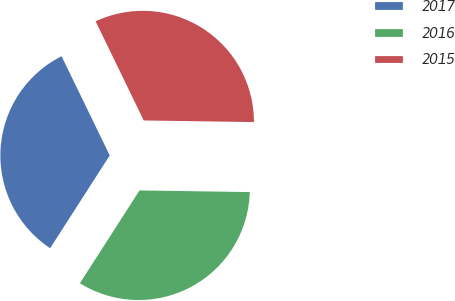<chart> <loc_0><loc_0><loc_500><loc_500><pie_chart><fcel>2017<fcel>2016<fcel>2015<nl><fcel>33.72%<fcel>33.85%<fcel>32.43%<nl></chart> 